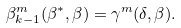<formula> <loc_0><loc_0><loc_500><loc_500>\beta ^ { m } _ { k - 1 } ( \beta ^ { * } , \beta ) = \gamma ^ { m } ( \delta , \beta ) .</formula> 